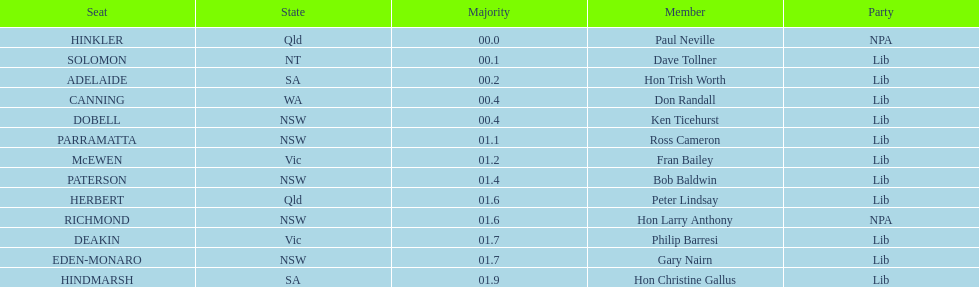Would you be able to parse every entry in this table? {'header': ['Seat', 'State', 'Majority', 'Member', 'Party'], 'rows': [['HINKLER', 'Qld', '00.0', 'Paul Neville', 'NPA'], ['SOLOMON', 'NT', '00.1', 'Dave Tollner', 'Lib'], ['ADELAIDE', 'SA', '00.2', 'Hon Trish Worth', 'Lib'], ['CANNING', 'WA', '00.4', 'Don Randall', 'Lib'], ['DOBELL', 'NSW', '00.4', 'Ken Ticehurst', 'Lib'], ['PARRAMATTA', 'NSW', '01.1', 'Ross Cameron', 'Lib'], ['McEWEN', 'Vic', '01.2', 'Fran Bailey', 'Lib'], ['PATERSON', 'NSW', '01.4', 'Bob Baldwin', 'Lib'], ['HERBERT', 'Qld', '01.6', 'Peter Lindsay', 'Lib'], ['RICHMOND', 'NSW', '01.6', 'Hon Larry Anthony', 'NPA'], ['DEAKIN', 'Vic', '01.7', 'Philip Barresi', 'Lib'], ['EDEN-MONARO', 'NSW', '01.7', 'Gary Nairn', 'Lib'], ['HINDMARSH', 'SA', '01.9', 'Hon Christine Gallus', 'Lib']]} What was the party with the highest number of seats? Lib. 